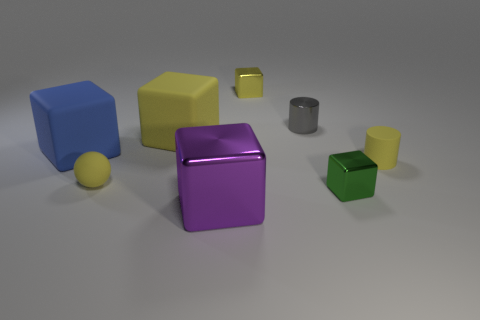Subtract all purple cubes. How many cubes are left? 4 Subtract all yellow rubber cubes. How many cubes are left? 4 Subtract all cyan cubes. Subtract all gray cylinders. How many cubes are left? 5 Add 2 large yellow objects. How many objects exist? 10 Subtract all cubes. How many objects are left? 3 Subtract 0 cyan cylinders. How many objects are left? 8 Subtract all small cubes. Subtract all small rubber things. How many objects are left? 4 Add 1 big purple cubes. How many big purple cubes are left? 2 Add 6 purple cubes. How many purple cubes exist? 7 